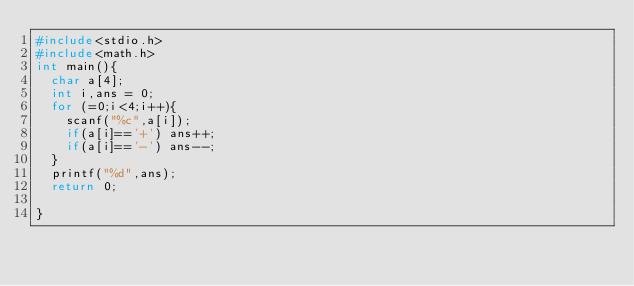<code> <loc_0><loc_0><loc_500><loc_500><_C_>#include<stdio.h>
#include<math.h>
int main(){
  char a[4];
  int i,ans = 0;
  for (=0;i<4;i++){
    scanf("%c",a[i]);
    if(a[i]=='+') ans++;
    if(a[i]=='-') ans--;
  }
  printf("%d",ans);
  return 0;
  
}</code> 